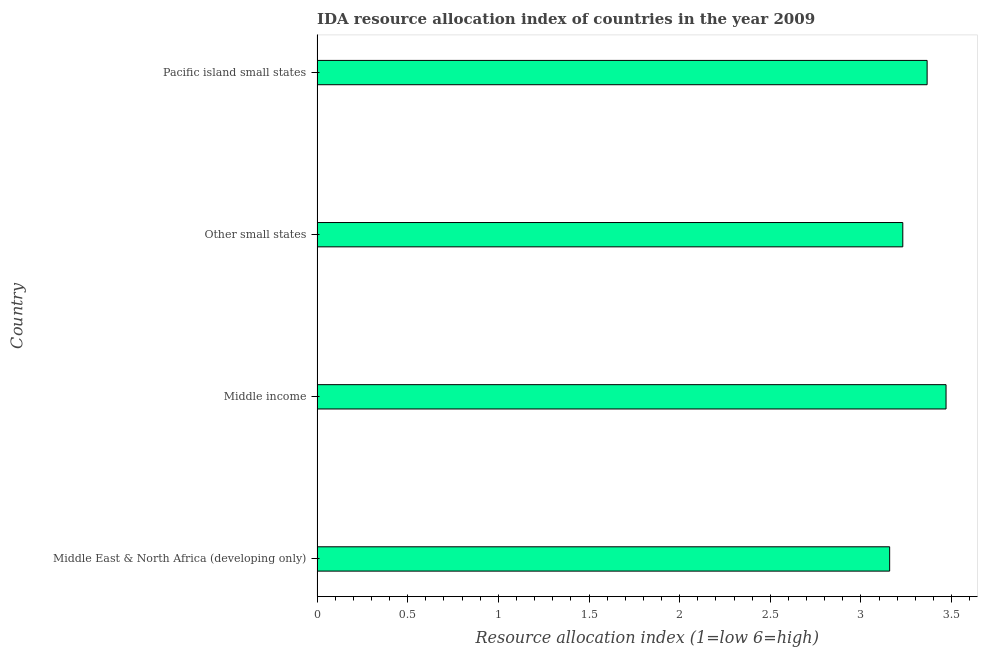Does the graph contain any zero values?
Provide a short and direct response. No. What is the title of the graph?
Make the answer very short. IDA resource allocation index of countries in the year 2009. What is the label or title of the X-axis?
Make the answer very short. Resource allocation index (1=low 6=high). What is the label or title of the Y-axis?
Offer a very short reply. Country. What is the ida resource allocation index in Middle East & North Africa (developing only)?
Your answer should be very brief. 3.16. Across all countries, what is the maximum ida resource allocation index?
Offer a very short reply. 3.47. Across all countries, what is the minimum ida resource allocation index?
Offer a terse response. 3.16. In which country was the ida resource allocation index maximum?
Your answer should be compact. Middle income. In which country was the ida resource allocation index minimum?
Ensure brevity in your answer.  Middle East & North Africa (developing only). What is the sum of the ida resource allocation index?
Provide a short and direct response. 13.22. What is the difference between the ida resource allocation index in Middle income and Pacific island small states?
Provide a short and direct response. 0.1. What is the average ida resource allocation index per country?
Give a very brief answer. 3.31. What is the median ida resource allocation index?
Offer a very short reply. 3.3. What is the ratio of the ida resource allocation index in Middle East & North Africa (developing only) to that in Other small states?
Your answer should be very brief. 0.98. Is the ida resource allocation index in Middle East & North Africa (developing only) less than that in Middle income?
Provide a short and direct response. Yes. Is the difference between the ida resource allocation index in Middle East & North Africa (developing only) and Pacific island small states greater than the difference between any two countries?
Give a very brief answer. No. What is the difference between the highest and the second highest ida resource allocation index?
Your response must be concise. 0.1. What is the difference between the highest and the lowest ida resource allocation index?
Offer a very short reply. 0.31. In how many countries, is the ida resource allocation index greater than the average ida resource allocation index taken over all countries?
Give a very brief answer. 2. Are all the bars in the graph horizontal?
Offer a terse response. Yes. How many countries are there in the graph?
Your answer should be very brief. 4. What is the Resource allocation index (1=low 6=high) in Middle East & North Africa (developing only)?
Your answer should be compact. 3.16. What is the Resource allocation index (1=low 6=high) of Middle income?
Give a very brief answer. 3.47. What is the Resource allocation index (1=low 6=high) in Other small states?
Your response must be concise. 3.23. What is the Resource allocation index (1=low 6=high) of Pacific island small states?
Offer a very short reply. 3.37. What is the difference between the Resource allocation index (1=low 6=high) in Middle East & North Africa (developing only) and Middle income?
Make the answer very short. -0.31. What is the difference between the Resource allocation index (1=low 6=high) in Middle East & North Africa (developing only) and Other small states?
Your answer should be compact. -0.07. What is the difference between the Resource allocation index (1=low 6=high) in Middle East & North Africa (developing only) and Pacific island small states?
Offer a very short reply. -0.21. What is the difference between the Resource allocation index (1=low 6=high) in Middle income and Other small states?
Give a very brief answer. 0.24. What is the difference between the Resource allocation index (1=low 6=high) in Middle income and Pacific island small states?
Keep it short and to the point. 0.1. What is the difference between the Resource allocation index (1=low 6=high) in Other small states and Pacific island small states?
Provide a succinct answer. -0.13. What is the ratio of the Resource allocation index (1=low 6=high) in Middle East & North Africa (developing only) to that in Middle income?
Provide a succinct answer. 0.91. What is the ratio of the Resource allocation index (1=low 6=high) in Middle East & North Africa (developing only) to that in Other small states?
Provide a succinct answer. 0.98. What is the ratio of the Resource allocation index (1=low 6=high) in Middle East & North Africa (developing only) to that in Pacific island small states?
Make the answer very short. 0.94. What is the ratio of the Resource allocation index (1=low 6=high) in Middle income to that in Other small states?
Give a very brief answer. 1.07. What is the ratio of the Resource allocation index (1=low 6=high) in Middle income to that in Pacific island small states?
Your answer should be very brief. 1.03. What is the ratio of the Resource allocation index (1=low 6=high) in Other small states to that in Pacific island small states?
Your answer should be very brief. 0.96. 